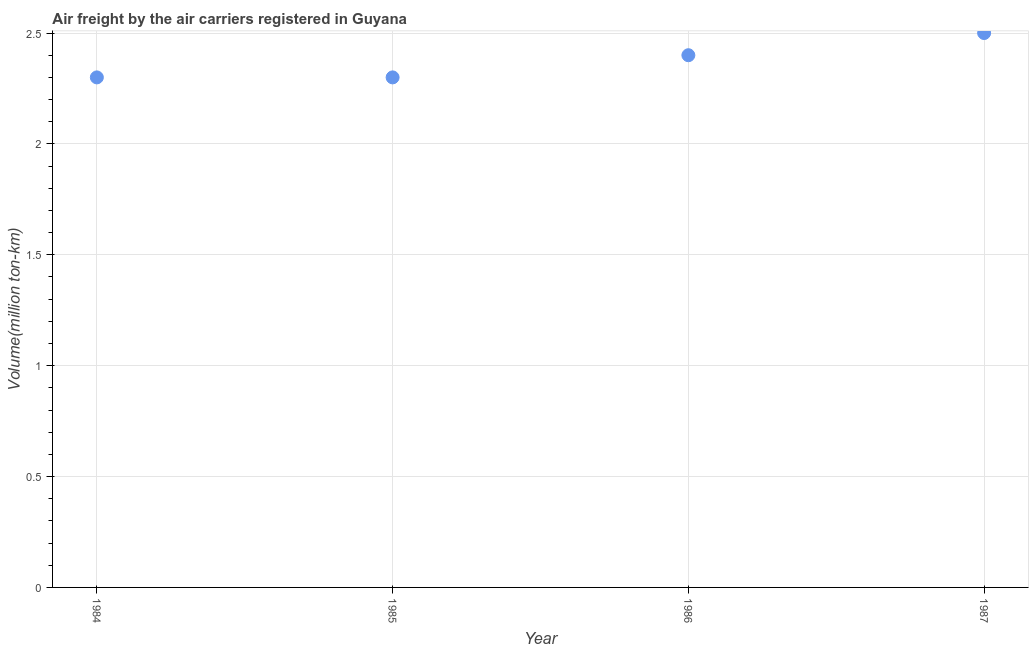What is the air freight in 1986?
Provide a short and direct response. 2.4. Across all years, what is the minimum air freight?
Provide a short and direct response. 2.3. What is the difference between the air freight in 1984 and 1986?
Your answer should be compact. -0.1. What is the average air freight per year?
Offer a terse response. 2.38. What is the median air freight?
Your answer should be very brief. 2.35. What is the ratio of the air freight in 1984 to that in 1986?
Your response must be concise. 0.96. Is the air freight in 1984 less than that in 1987?
Keep it short and to the point. Yes. What is the difference between the highest and the second highest air freight?
Your answer should be compact. 0.1. What is the difference between the highest and the lowest air freight?
Make the answer very short. 0.2. In how many years, is the air freight greater than the average air freight taken over all years?
Your answer should be very brief. 2. Does the air freight monotonically increase over the years?
Provide a succinct answer. No. How many years are there in the graph?
Give a very brief answer. 4. What is the difference between two consecutive major ticks on the Y-axis?
Your response must be concise. 0.5. Does the graph contain any zero values?
Keep it short and to the point. No. What is the title of the graph?
Keep it short and to the point. Air freight by the air carriers registered in Guyana. What is the label or title of the Y-axis?
Offer a terse response. Volume(million ton-km). What is the Volume(million ton-km) in 1984?
Offer a very short reply. 2.3. What is the Volume(million ton-km) in 1985?
Ensure brevity in your answer.  2.3. What is the Volume(million ton-km) in 1986?
Your answer should be compact. 2.4. What is the difference between the Volume(million ton-km) in 1984 and 1985?
Provide a succinct answer. 0. What is the difference between the Volume(million ton-km) in 1984 and 1986?
Give a very brief answer. -0.1. What is the difference between the Volume(million ton-km) in 1985 and 1987?
Make the answer very short. -0.2. What is the ratio of the Volume(million ton-km) in 1984 to that in 1986?
Make the answer very short. 0.96. What is the ratio of the Volume(million ton-km) in 1985 to that in 1986?
Your answer should be compact. 0.96. What is the ratio of the Volume(million ton-km) in 1985 to that in 1987?
Offer a very short reply. 0.92. What is the ratio of the Volume(million ton-km) in 1986 to that in 1987?
Your answer should be compact. 0.96. 